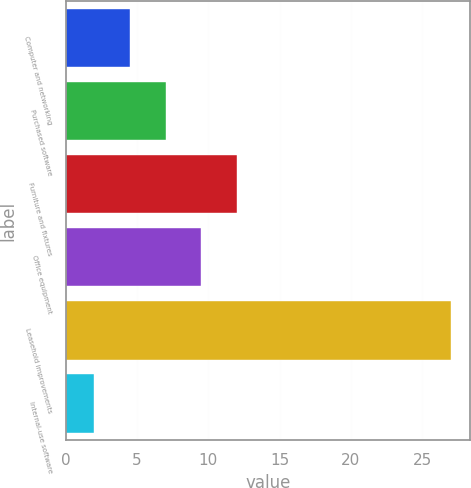Convert chart to OTSL. <chart><loc_0><loc_0><loc_500><loc_500><bar_chart><fcel>Computer and networking<fcel>Purchased software<fcel>Furniture and fixtures<fcel>Office equipment<fcel>Leasehold improvements<fcel>Internal-use software<nl><fcel>4.5<fcel>7<fcel>12<fcel>9.5<fcel>27<fcel>2<nl></chart> 